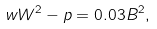<formula> <loc_0><loc_0><loc_500><loc_500>w W ^ { 2 } - p = 0 . 0 3 B ^ { 2 } ,</formula> 